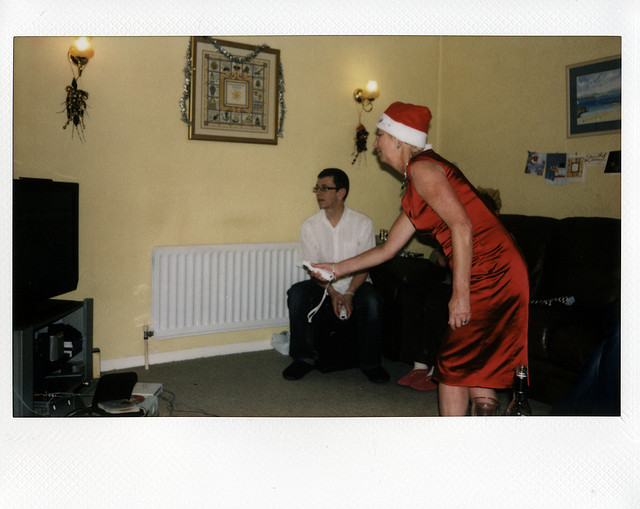<image>What animal is all over the wall? I'm not sure which animal is all over the wall, if any. It can be either a cat, bat, bird, or cockroach, or there may be no animal at all. What animal is all over the wall? I don't know what animal is all over the wall. It can be seen as 'cat', 'bat', 'bird', or 'cockroach'. 